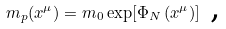Convert formula to latex. <formula><loc_0><loc_0><loc_500><loc_500>m _ { p } ( x ^ { \mu } ) = m _ { 0 } \exp [ \Phi _ { N } \left ( x ^ { \mu } \right ) ] \text { ,}</formula> 